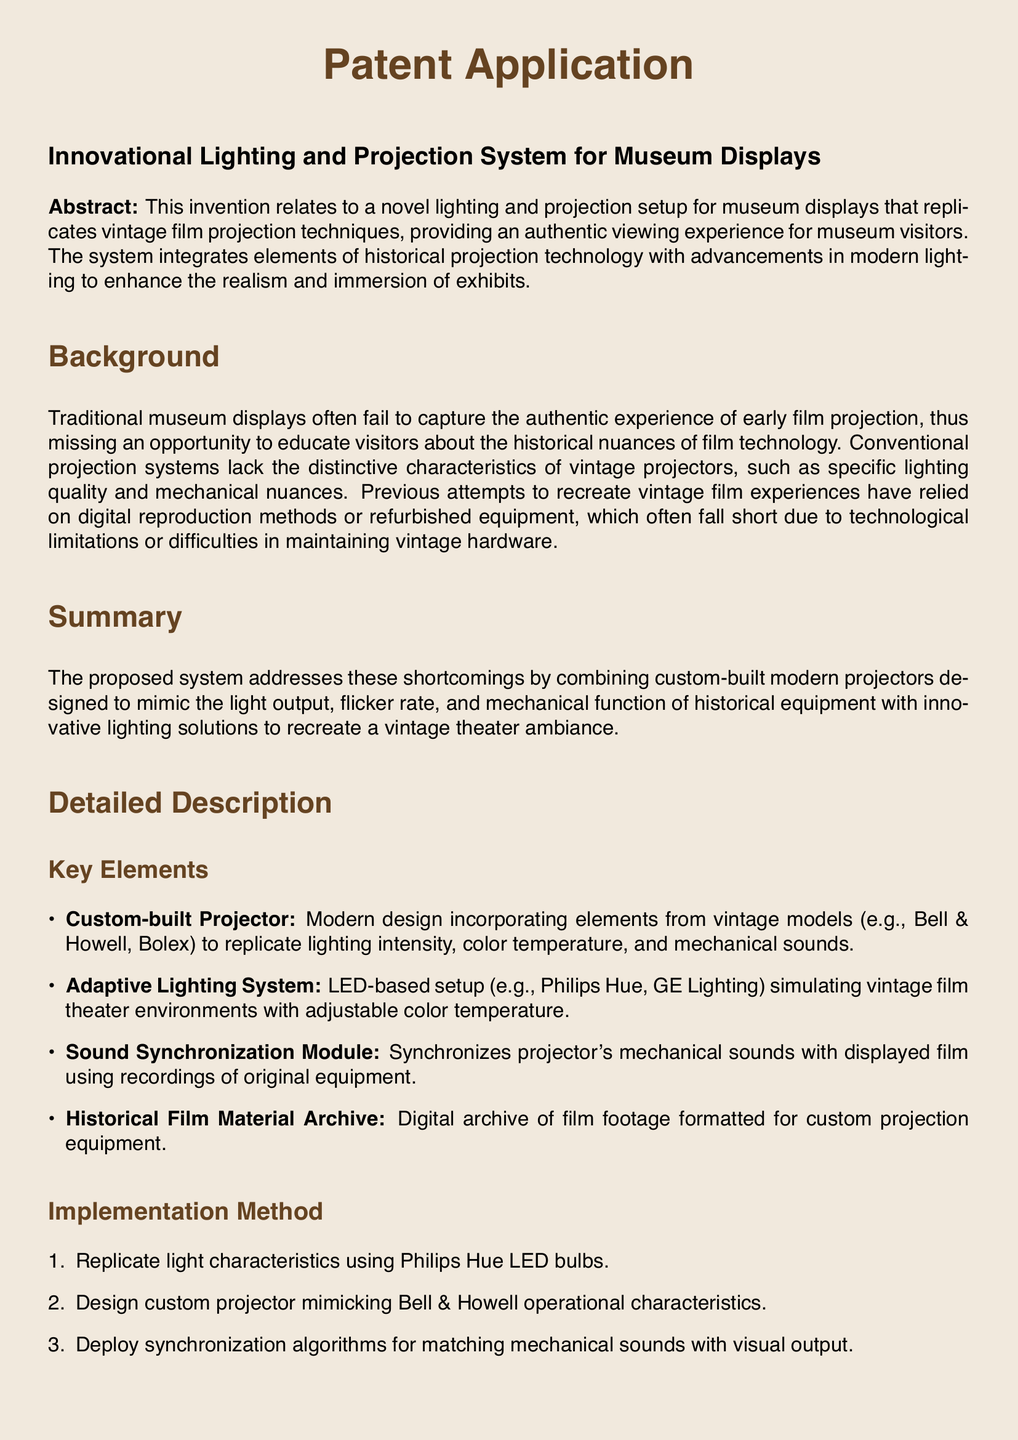What is the title of the invention? The title of the invention is stated at the beginning of the document as "Innovational Lighting and Projection System for Museum Displays."
Answer: Innovational Lighting and Projection System for Museum Displays What does the adaptive lighting system utilize? The adaptive lighting system utilizes LED technology to simulate vintage theater lighting environments, as stated in the claims section.
Answer: LED technology How many claims are made in the document? The claims section outlines a total of five distinct claims regarding the invention.
Answer: Five What are the first two components listed in the key elements? The key elements list begins with a custom-built projector and an adaptive lighting system.
Answer: Custom-built Projector, Adaptive Lighting System What is the purpose of the sound synchronization module? The purpose of the sound synchronization module is to synchronize the projector's mechanical sounds with the displayed film using recordings of original equipment.
Answer: Synchronize mechanical sounds What is the first step in the implementation method? The first step in the implementation method is to replicate light characteristics using Philips Hue LED bulbs.
Answer: Replicate light characteristics What historical film equipment is the custom projector designed to mimic? The custom projector is designed to mimic operational characteristics from Bell & Howell projectors.
Answer: Bell & Howell What does the historical film material archive consist of? The historical film material archive consists of digital copies of early film footage formatted for deployment through custom-built projection equipment.
Answer: Digital copies of early film footage 